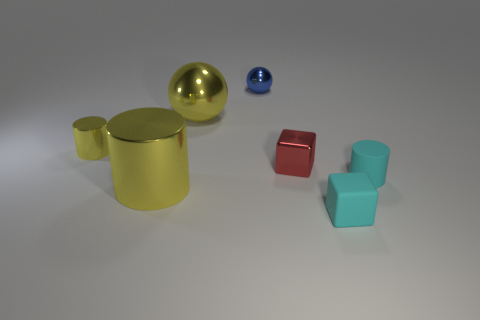What is the material of the tiny cylinder that is the same color as the rubber block?
Offer a terse response. Rubber. Does the yellow shiny object that is behind the tiny yellow metallic cylinder have the same shape as the large yellow object that is to the left of the big yellow shiny ball?
Keep it short and to the point. No. Are there fewer tiny blue metallic objects on the right side of the tiny red block than large metal spheres that are on the left side of the tiny yellow cylinder?
Give a very brief answer. No. What number of other objects are there of the same shape as the tiny yellow thing?
Make the answer very short. 2. There is a big yellow object that is made of the same material as the big sphere; what shape is it?
Your answer should be very brief. Cylinder. The tiny metallic object that is both to the right of the big yellow cylinder and behind the red cube is what color?
Your response must be concise. Blue. Do the yellow sphere left of the small red object and the tiny cyan cylinder have the same material?
Ensure brevity in your answer.  No. Are there fewer small cyan rubber blocks that are left of the large metallic cylinder than red objects?
Your response must be concise. Yes. Is there another yellow cylinder that has the same material as the tiny yellow cylinder?
Provide a succinct answer. Yes. Is the size of the yellow metallic sphere the same as the yellow metal thing in front of the tiny red object?
Offer a very short reply. Yes. 